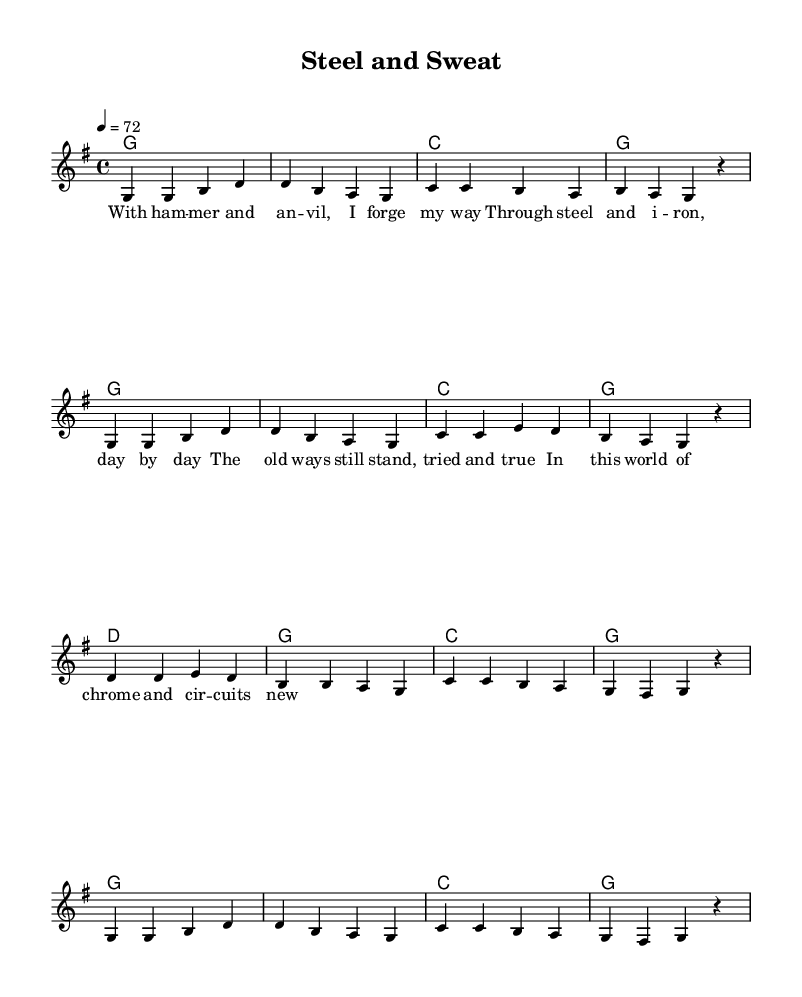What is the key signature of this music? The key signature is G major, which has one sharp (F#). This can be determined by looking at the key signature indicated at the beginning of the sheet music.
Answer: G major What is the time signature of this music? The time signature is 4/4, which can be found at the beginning of the sheet music next to the key signature. This indicates that there are four beats in each measure and a quarter note gets one beat.
Answer: 4/4 What is the tempo marking provided in the sheet music? The tempo marking is 72 beats per minute as indicated by "4 = 72." This indicates the speed at which the music should be played.
Answer: 72 How many measures are present in this piece? Counting the measures in the melody section shows there are a total of 8 measures. Each group of notes separated by vertical lines represents one measure.
Answer: 8 Which line represents the lyrics in the sheet music? The lyrics are placed beneath the melody staff, aligned with the notes they correspond with. This is a common practice in sheet music to indicate vocal lines.
Answer: Lead What themes do the lyrics of this ballad celebrate? The lyrics celebrate traditional craftsmanship and engineering, emphasizing values such as hard work and the enduring nature of traditional methods. This can be deduced from the context of the lyrics provided in the verses.
Answer: Traditional craftsmanship What musical structure does this ballad exhibit? The structure of this ballad can be identified as a verse-chorus form, where the verse presents the story and emotions, common in country music. This reflects the storytelling tradition in classic country ballads.
Answer: Verse-chorus 